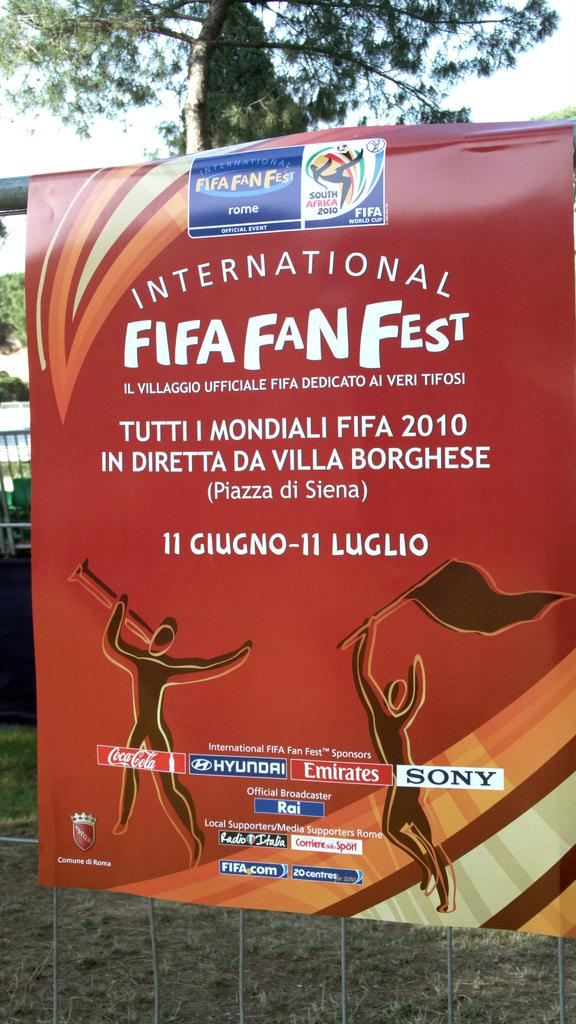Provide a one-sentence caption for the provided image. A small sign board displaying a logo for the Fifa Fan Fest. 